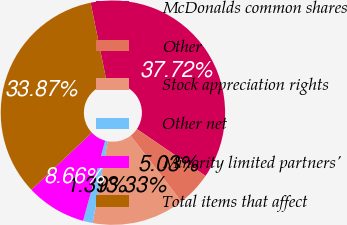<chart> <loc_0><loc_0><loc_500><loc_500><pie_chart><fcel>McDonalds common shares<fcel>Other<fcel>Stock appreciation rights<fcel>Other net<fcel>Minority limited partners'<fcel>Total items that affect<nl><fcel>37.72%<fcel>5.03%<fcel>13.33%<fcel>1.39%<fcel>8.66%<fcel>33.87%<nl></chart> 